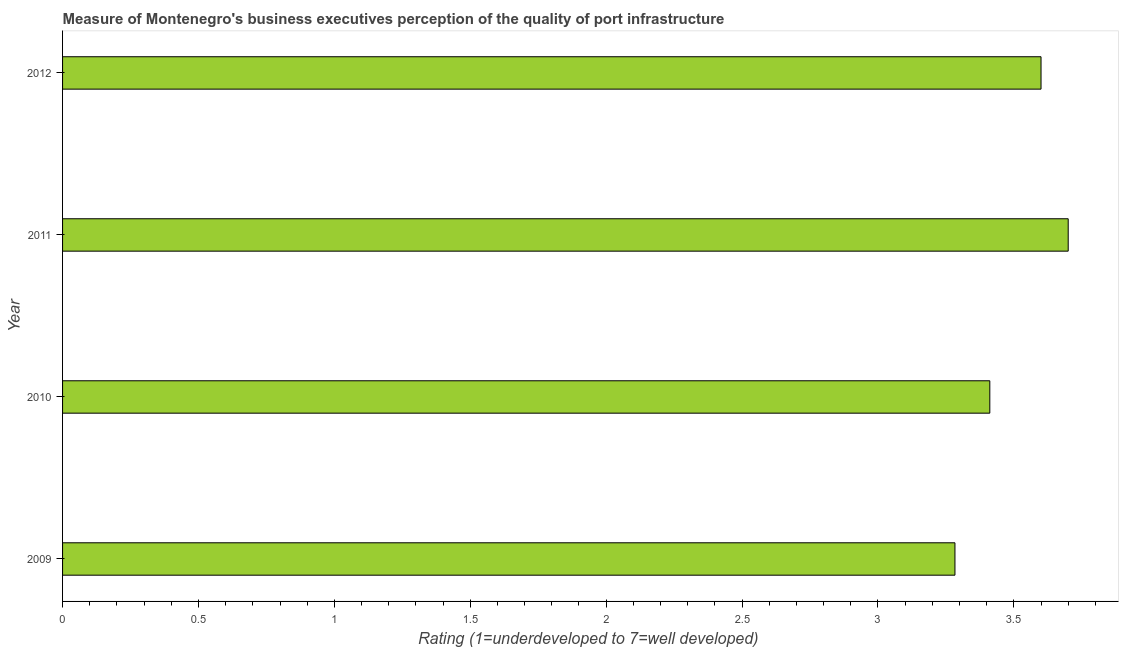What is the title of the graph?
Offer a very short reply. Measure of Montenegro's business executives perception of the quality of port infrastructure. What is the label or title of the X-axis?
Your response must be concise. Rating (1=underdeveloped to 7=well developed) . What is the label or title of the Y-axis?
Your answer should be compact. Year. What is the rating measuring quality of port infrastructure in 2010?
Ensure brevity in your answer.  3.41. Across all years, what is the minimum rating measuring quality of port infrastructure?
Keep it short and to the point. 3.28. What is the sum of the rating measuring quality of port infrastructure?
Ensure brevity in your answer.  13.99. What is the difference between the rating measuring quality of port infrastructure in 2010 and 2012?
Ensure brevity in your answer.  -0.19. What is the average rating measuring quality of port infrastructure per year?
Offer a terse response. 3.5. What is the median rating measuring quality of port infrastructure?
Your answer should be compact. 3.51. In how many years, is the rating measuring quality of port infrastructure greater than 0.9 ?
Ensure brevity in your answer.  4. What is the ratio of the rating measuring quality of port infrastructure in 2009 to that in 2012?
Your answer should be very brief. 0.91. Is the rating measuring quality of port infrastructure in 2010 less than that in 2011?
Ensure brevity in your answer.  Yes. Is the difference between the rating measuring quality of port infrastructure in 2009 and 2012 greater than the difference between any two years?
Your answer should be compact. No. What is the difference between the highest and the second highest rating measuring quality of port infrastructure?
Give a very brief answer. 0.1. Is the sum of the rating measuring quality of port infrastructure in 2009 and 2010 greater than the maximum rating measuring quality of port infrastructure across all years?
Offer a very short reply. Yes. What is the difference between the highest and the lowest rating measuring quality of port infrastructure?
Make the answer very short. 0.42. In how many years, is the rating measuring quality of port infrastructure greater than the average rating measuring quality of port infrastructure taken over all years?
Your answer should be compact. 2. What is the difference between two consecutive major ticks on the X-axis?
Offer a very short reply. 0.5. What is the Rating (1=underdeveloped to 7=well developed)  of 2009?
Your answer should be compact. 3.28. What is the Rating (1=underdeveloped to 7=well developed)  of 2010?
Your answer should be very brief. 3.41. What is the difference between the Rating (1=underdeveloped to 7=well developed)  in 2009 and 2010?
Offer a very short reply. -0.13. What is the difference between the Rating (1=underdeveloped to 7=well developed)  in 2009 and 2011?
Ensure brevity in your answer.  -0.42. What is the difference between the Rating (1=underdeveloped to 7=well developed)  in 2009 and 2012?
Your answer should be very brief. -0.32. What is the difference between the Rating (1=underdeveloped to 7=well developed)  in 2010 and 2011?
Your answer should be very brief. -0.29. What is the difference between the Rating (1=underdeveloped to 7=well developed)  in 2010 and 2012?
Ensure brevity in your answer.  -0.19. What is the difference between the Rating (1=underdeveloped to 7=well developed)  in 2011 and 2012?
Your answer should be very brief. 0.1. What is the ratio of the Rating (1=underdeveloped to 7=well developed)  in 2009 to that in 2010?
Keep it short and to the point. 0.96. What is the ratio of the Rating (1=underdeveloped to 7=well developed)  in 2009 to that in 2011?
Your answer should be compact. 0.89. What is the ratio of the Rating (1=underdeveloped to 7=well developed)  in 2009 to that in 2012?
Your response must be concise. 0.91. What is the ratio of the Rating (1=underdeveloped to 7=well developed)  in 2010 to that in 2011?
Your answer should be compact. 0.92. What is the ratio of the Rating (1=underdeveloped to 7=well developed)  in 2010 to that in 2012?
Offer a very short reply. 0.95. What is the ratio of the Rating (1=underdeveloped to 7=well developed)  in 2011 to that in 2012?
Provide a short and direct response. 1.03. 